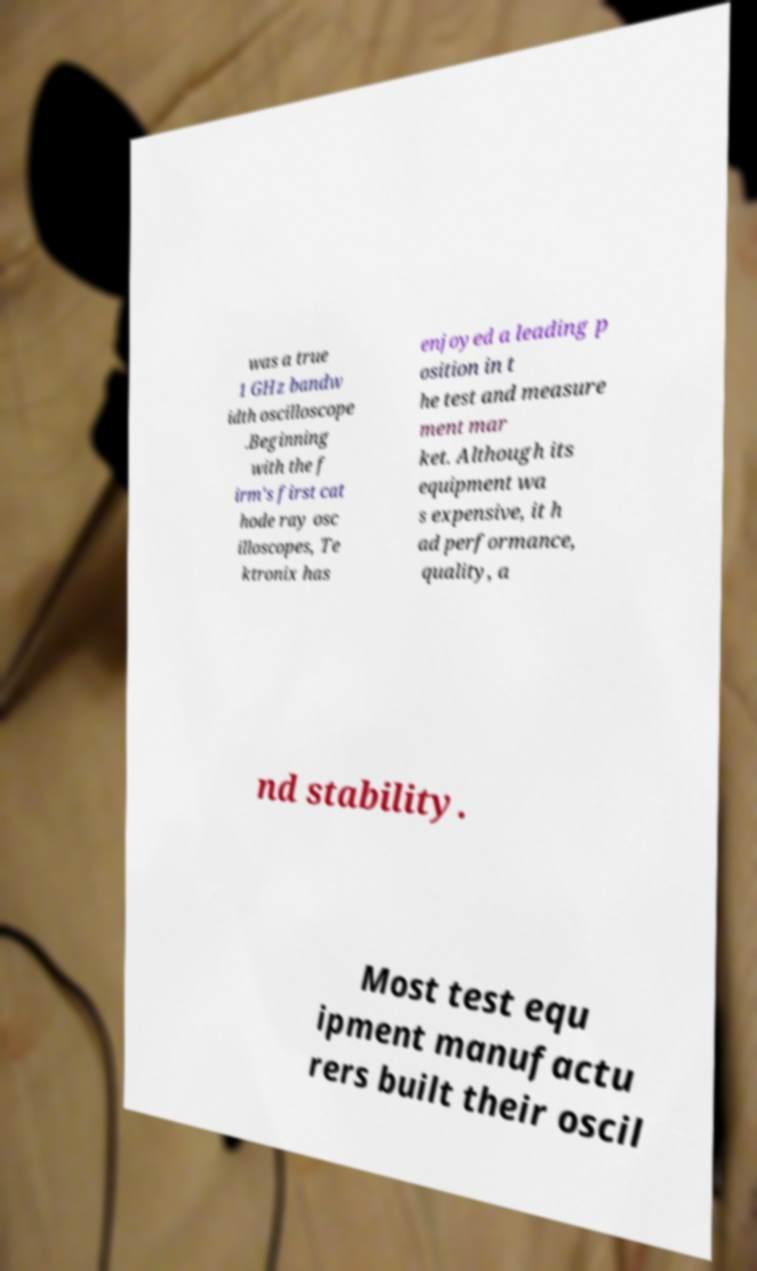Please read and relay the text visible in this image. What does it say? was a true 1 GHz bandw idth oscilloscope .Beginning with the f irm's first cat hode ray osc illoscopes, Te ktronix has enjoyed a leading p osition in t he test and measure ment mar ket. Although its equipment wa s expensive, it h ad performance, quality, a nd stability. Most test equ ipment manufactu rers built their oscil 